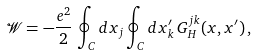<formula> <loc_0><loc_0><loc_500><loc_500>\mathcal { W } = - \frac { e ^ { 2 } } { 2 } \, \oint _ { C } d x _ { j } \oint _ { C } d x ^ { \prime } _ { k } \, G _ { H } ^ { j k } ( x , x ^ { \prime } ) \, ,</formula> 